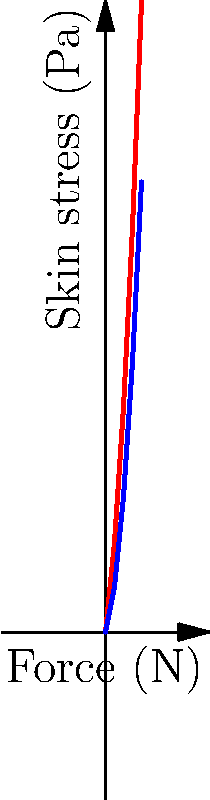The graph shows the relationship between applied force and skin stress for two different makeup application techniques. Based on the force diagram, calculate the difference in skin stress between heavy and light application techniques when a force of 3 N is applied. Express your answer in Pascals (Pa). To solve this problem, we need to follow these steps:

1. Identify the skin stress for heavy application at 3 N:
   From the red line (heavy application), we can see that at 3 N, the skin stress is approximately 45 Pa.

2. Identify the skin stress for light application at 3 N:
   From the blue line (light application), we can see that at 3 N, the skin stress is approximately 30 Pa.

3. Calculate the difference in skin stress:
   $$\text{Difference} = \text{Heavy application stress} - \text{Light application stress}$$
   $$\text{Difference} = 45 \text{ Pa} - 30 \text{ Pa} = 15 \text{ Pa}$$

Therefore, the difference in skin stress between heavy and light application techniques when a force of 3 N is applied is 15 Pa.
Answer: 15 Pa 